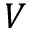Convert formula to latex. <formula><loc_0><loc_0><loc_500><loc_500>V</formula> 